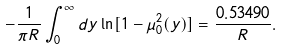<formula> <loc_0><loc_0><loc_500><loc_500>- \frac { 1 } { \pi R } \int _ { 0 } ^ { \infty } d y \ln [ 1 - \mu _ { 0 } ^ { 2 } ( y ) ] = \frac { 0 . 5 3 4 9 0 } { R } { . }</formula> 